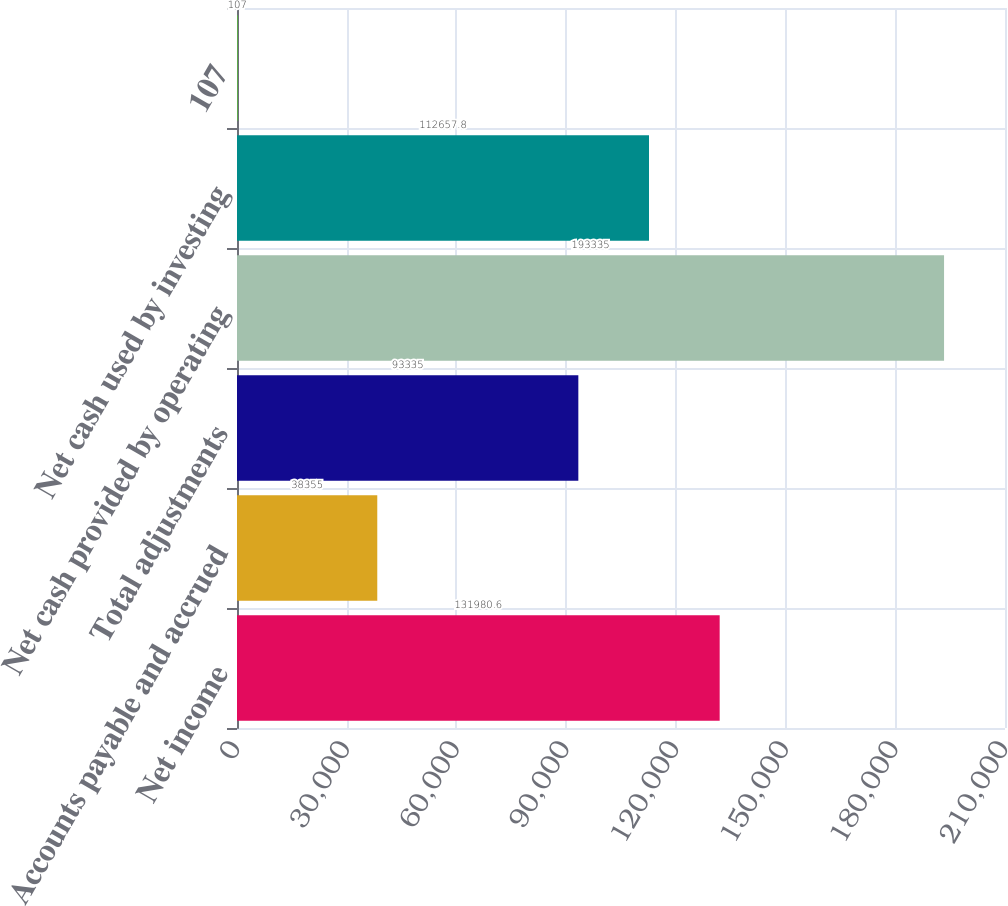Convert chart. <chart><loc_0><loc_0><loc_500><loc_500><bar_chart><fcel>Net income<fcel>Accounts payable and accrued<fcel>Total adjustments<fcel>Net cash provided by operating<fcel>Net cash used by investing<fcel>107<nl><fcel>131981<fcel>38355<fcel>93335<fcel>193335<fcel>112658<fcel>107<nl></chart> 